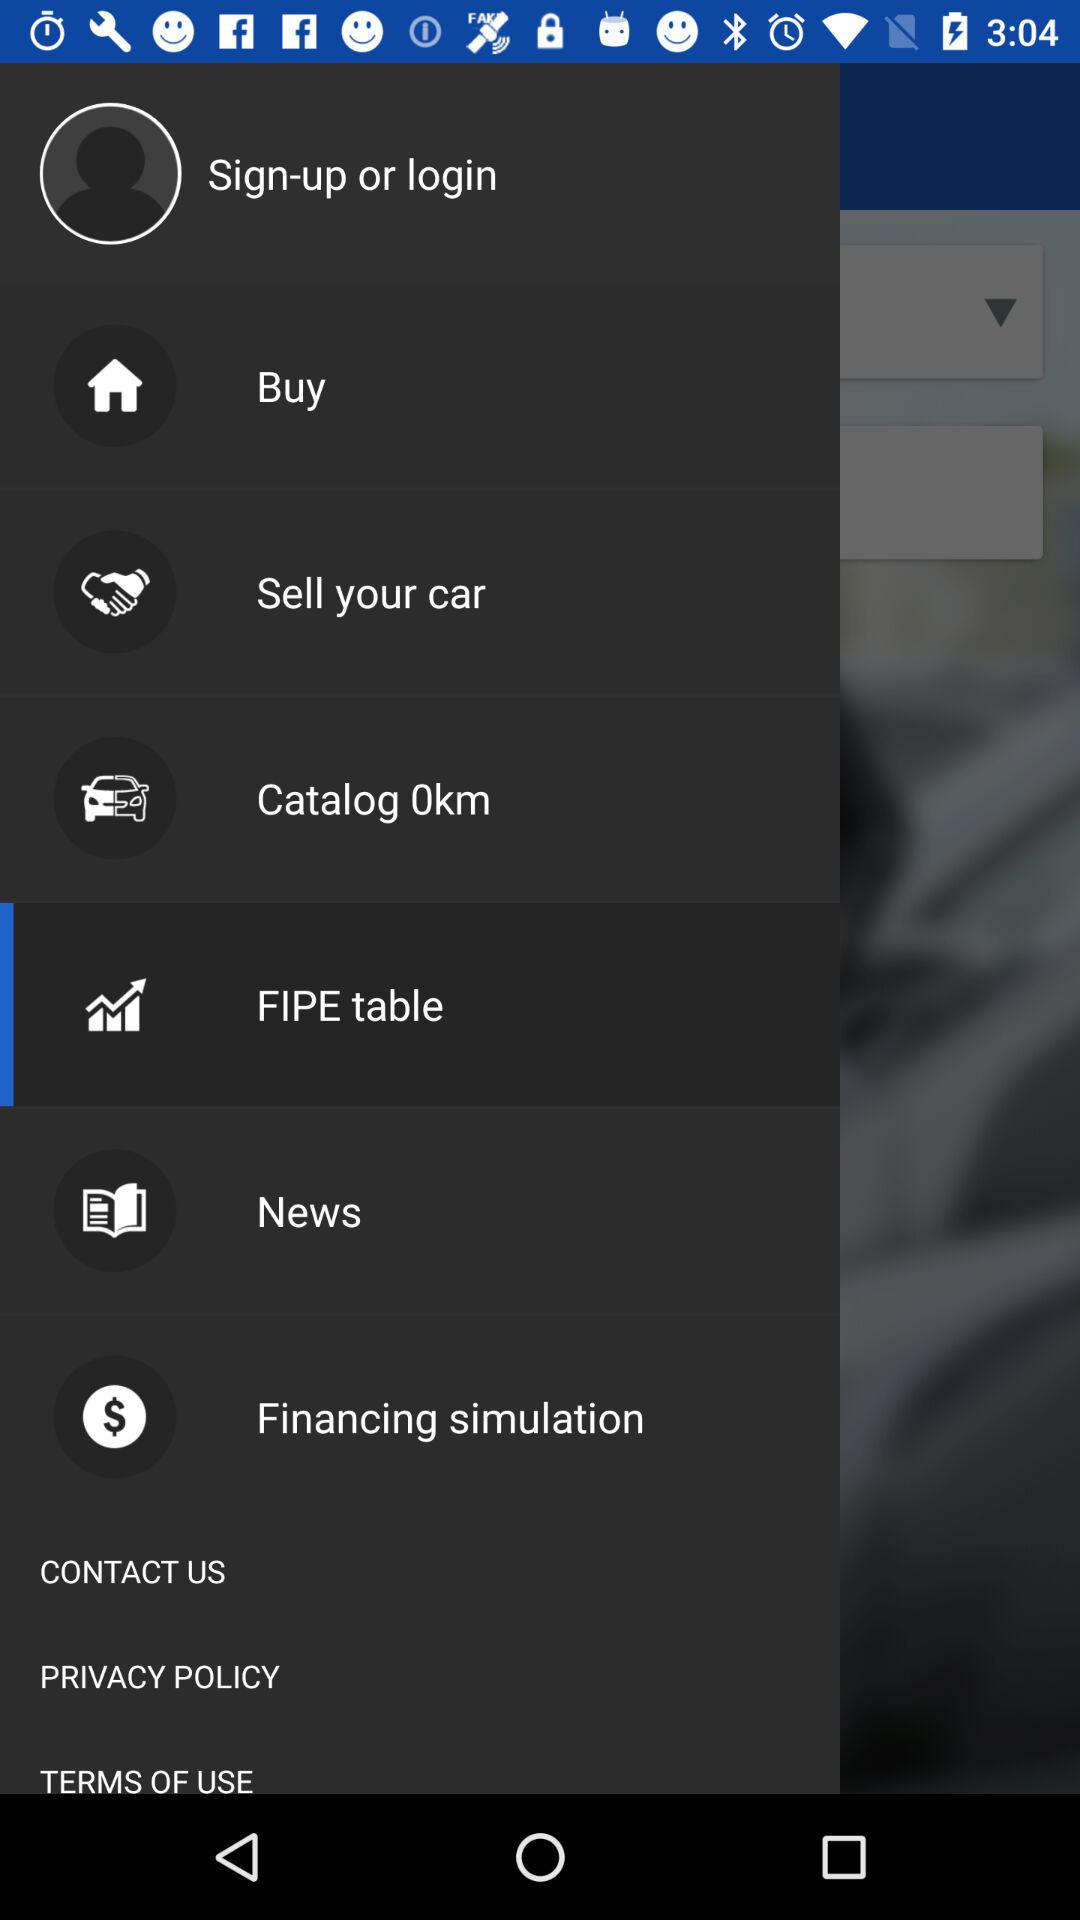Which item is selected? The selected item is "FIPE table". 